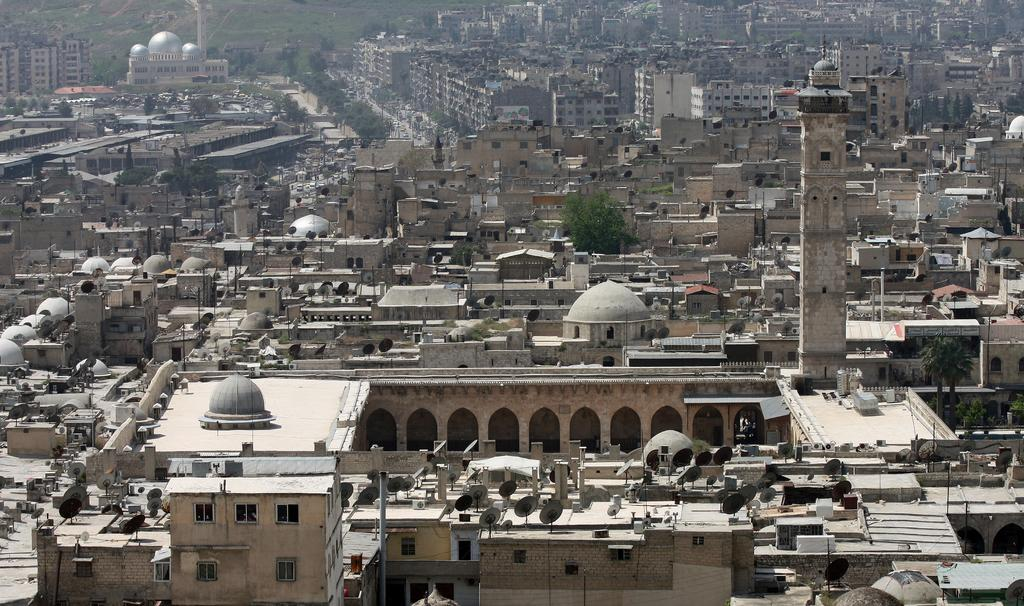What type of structures can be seen in the image? There are buildings in the image. What type of vegetation is visible in the image? There are trees in the image. Can you see any signs of a protest happening in the image? There is no indication of a protest in the image. Is the image taken during the night? The information provided does not specify the time of day, so it cannot be determined if the image was taken during the night. Is there any lace visible in the image? There is no mention of lace in the provided facts, so it cannot be determined if there is any lace visible in the image. 